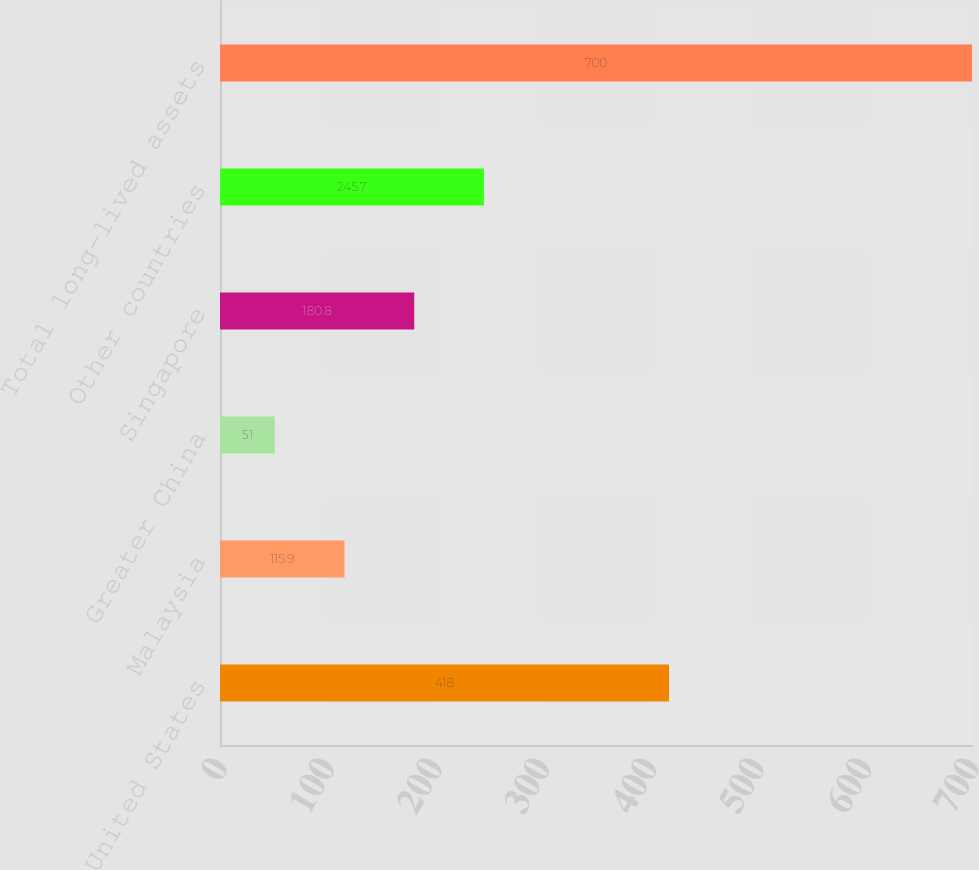<chart> <loc_0><loc_0><loc_500><loc_500><bar_chart><fcel>United States<fcel>Malaysia<fcel>Greater China<fcel>Singapore<fcel>Other countries<fcel>Total long-lived assets<nl><fcel>418<fcel>115.9<fcel>51<fcel>180.8<fcel>245.7<fcel>700<nl></chart> 